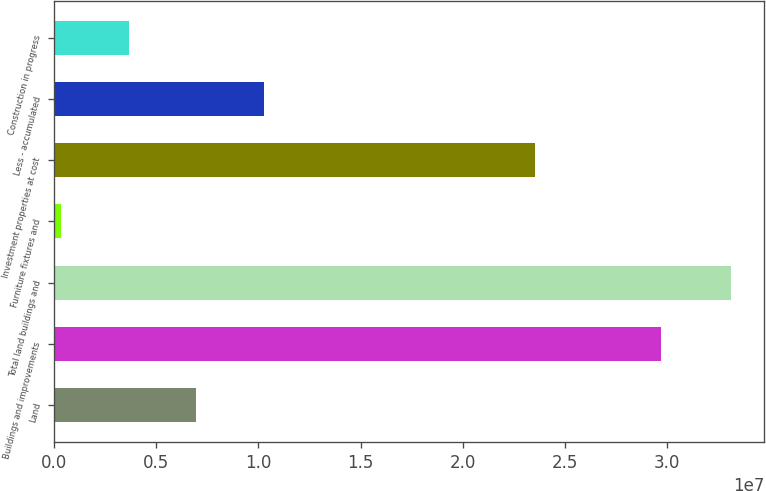Convert chart. <chart><loc_0><loc_0><loc_500><loc_500><bar_chart><fcel>Land<fcel>Buildings and improvements<fcel>Total land buildings and<fcel>Furniture fixtures and<fcel>Investment properties at cost<fcel>Less - accumulated<fcel>Construction in progress<nl><fcel>6.95682e+06<fcel>2.97152e+07<fcel>3.31329e+07<fcel>330239<fcel>2.35477e+07<fcel>1.02701e+07<fcel>3.64353e+06<nl></chart> 